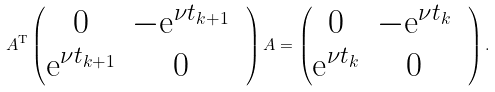Convert formula to latex. <formula><loc_0><loc_0><loc_500><loc_500>A ^ { \text {T} } \begin{pmatrix} 0 & - \text {e} ^ { \nu t _ { k + 1 } } & \\ \text {e} ^ { \nu t _ { k + 1 } } & 0 \end{pmatrix} A = \begin{pmatrix} 0 & - \text {e} ^ { \nu t _ { k } } & \\ \text {e} ^ { \nu t _ { k } } & 0 & \end{pmatrix} .</formula> 